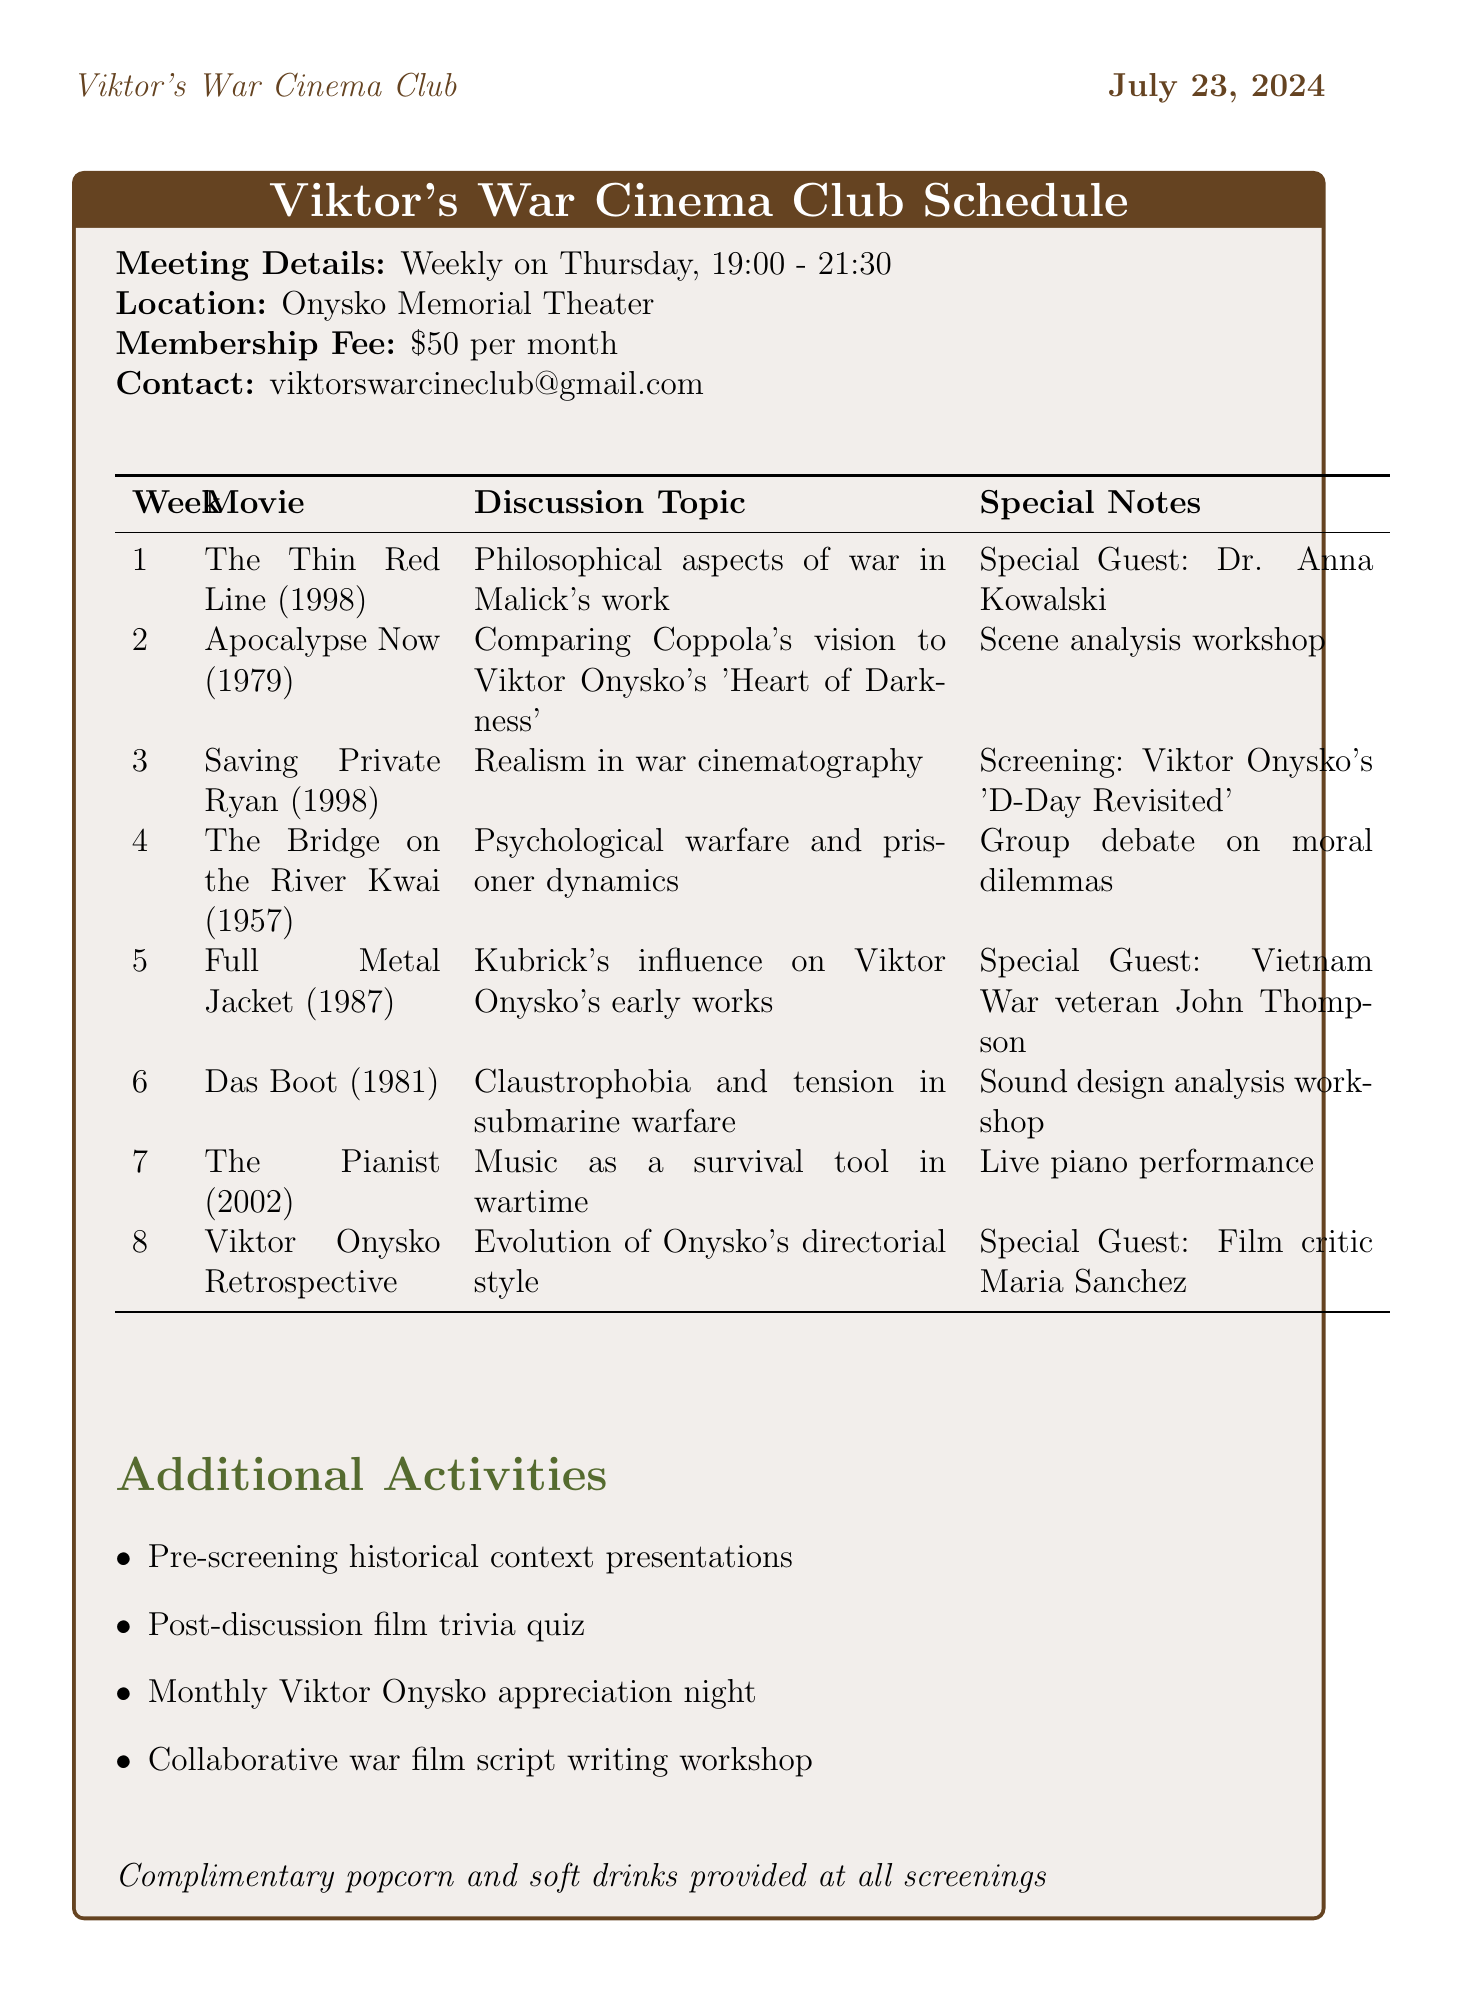What is the name of the group? The name of the group is provided at the beginning of the document under the title section.
Answer: Viktor's War Cinema Club How often does the group meet? The meeting frequency is stated in the meeting details section of the document.
Answer: Weekly What is the meeting location? The meeting location is specified in the meeting details section.
Answer: Onysko Memorial Theater Who is the special guest for week 5? The special guest for week 5 is mentioned next to the movie title in the schedule.
Answer: Vietnam War veteran John Thompson What movie will be screened in week 3? The movie scheduled for week 3 is listed directly in the schedule table.
Answer: Saving Private Ryan Which film is discussed in week 2? The film discussed in week 2 can be found in the schedule where the week and movie title are listed.
Answer: Apocalypse Now What is the discussion topic for week 6? The discussion topic for week 6 is detailed in the schedule alongside the movie title.
Answer: Claustrophobia and tension in submarine warfare What type of activity is planned for week 4? The type of activity for week 4 is mentioned in the schedule under special notes.
Answer: Group debate on moral dilemmas in wartime What is one of the additional activities listed? The additional activities are listed in a bullet-point format.
Answer: Pre-screening historical context presentations 